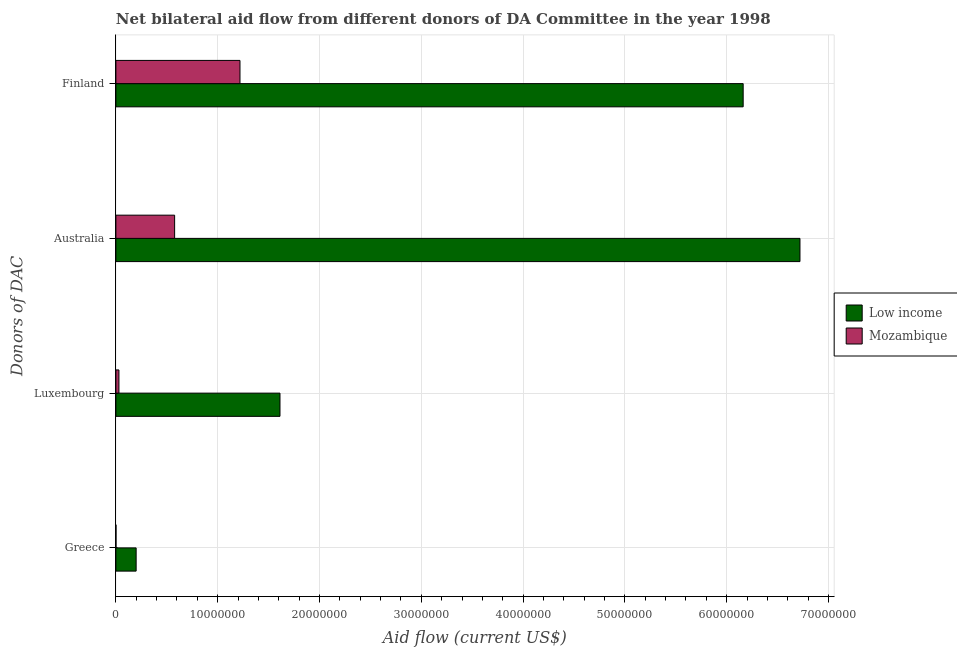How many groups of bars are there?
Provide a succinct answer. 4. What is the amount of aid given by greece in Mozambique?
Keep it short and to the point. 10000. Across all countries, what is the maximum amount of aid given by greece?
Your answer should be very brief. 1.99e+06. Across all countries, what is the minimum amount of aid given by greece?
Make the answer very short. 10000. In which country was the amount of aid given by greece minimum?
Offer a terse response. Mozambique. What is the total amount of aid given by greece in the graph?
Offer a terse response. 2.00e+06. What is the difference between the amount of aid given by luxembourg in Mozambique and that in Low income?
Keep it short and to the point. -1.58e+07. What is the difference between the amount of aid given by australia in Low income and the amount of aid given by finland in Mozambique?
Offer a very short reply. 5.50e+07. What is the average amount of aid given by finland per country?
Offer a very short reply. 3.69e+07. What is the difference between the amount of aid given by finland and amount of aid given by luxembourg in Low income?
Keep it short and to the point. 4.55e+07. What is the ratio of the amount of aid given by greece in Mozambique to that in Low income?
Offer a very short reply. 0.01. Is the amount of aid given by luxembourg in Mozambique less than that in Low income?
Give a very brief answer. Yes. Is the difference between the amount of aid given by luxembourg in Mozambique and Low income greater than the difference between the amount of aid given by finland in Mozambique and Low income?
Your answer should be very brief. Yes. What is the difference between the highest and the second highest amount of aid given by greece?
Offer a very short reply. 1.98e+06. What is the difference between the highest and the lowest amount of aid given by finland?
Ensure brevity in your answer.  4.94e+07. In how many countries, is the amount of aid given by luxembourg greater than the average amount of aid given by luxembourg taken over all countries?
Offer a terse response. 1. Is the sum of the amount of aid given by greece in Low income and Mozambique greater than the maximum amount of aid given by australia across all countries?
Keep it short and to the point. No. What does the 2nd bar from the top in Australia represents?
Make the answer very short. Low income. What does the 2nd bar from the bottom in Greece represents?
Offer a terse response. Mozambique. What is the difference between two consecutive major ticks on the X-axis?
Provide a short and direct response. 1.00e+07. Does the graph contain grids?
Provide a succinct answer. Yes. How many legend labels are there?
Offer a very short reply. 2. What is the title of the graph?
Offer a terse response. Net bilateral aid flow from different donors of DA Committee in the year 1998. Does "Tonga" appear as one of the legend labels in the graph?
Give a very brief answer. No. What is the label or title of the X-axis?
Your answer should be compact. Aid flow (current US$). What is the label or title of the Y-axis?
Your answer should be very brief. Donors of DAC. What is the Aid flow (current US$) of Low income in Greece?
Provide a succinct answer. 1.99e+06. What is the Aid flow (current US$) of Low income in Luxembourg?
Ensure brevity in your answer.  1.61e+07. What is the Aid flow (current US$) of Low income in Australia?
Provide a short and direct response. 6.72e+07. What is the Aid flow (current US$) of Mozambique in Australia?
Keep it short and to the point. 5.77e+06. What is the Aid flow (current US$) in Low income in Finland?
Offer a very short reply. 6.16e+07. What is the Aid flow (current US$) of Mozambique in Finland?
Your answer should be very brief. 1.22e+07. Across all Donors of DAC, what is the maximum Aid flow (current US$) of Low income?
Your answer should be very brief. 6.72e+07. Across all Donors of DAC, what is the maximum Aid flow (current US$) in Mozambique?
Offer a very short reply. 1.22e+07. Across all Donors of DAC, what is the minimum Aid flow (current US$) in Low income?
Give a very brief answer. 1.99e+06. What is the total Aid flow (current US$) in Low income in the graph?
Ensure brevity in your answer.  1.47e+08. What is the total Aid flow (current US$) in Mozambique in the graph?
Give a very brief answer. 1.83e+07. What is the difference between the Aid flow (current US$) of Low income in Greece and that in Luxembourg?
Your response must be concise. -1.41e+07. What is the difference between the Aid flow (current US$) in Low income in Greece and that in Australia?
Your response must be concise. -6.52e+07. What is the difference between the Aid flow (current US$) of Mozambique in Greece and that in Australia?
Keep it short and to the point. -5.76e+06. What is the difference between the Aid flow (current US$) in Low income in Greece and that in Finland?
Ensure brevity in your answer.  -5.96e+07. What is the difference between the Aid flow (current US$) of Mozambique in Greece and that in Finland?
Keep it short and to the point. -1.22e+07. What is the difference between the Aid flow (current US$) of Low income in Luxembourg and that in Australia?
Provide a short and direct response. -5.11e+07. What is the difference between the Aid flow (current US$) in Mozambique in Luxembourg and that in Australia?
Your answer should be compact. -5.47e+06. What is the difference between the Aid flow (current US$) of Low income in Luxembourg and that in Finland?
Make the answer very short. -4.55e+07. What is the difference between the Aid flow (current US$) in Mozambique in Luxembourg and that in Finland?
Keep it short and to the point. -1.19e+07. What is the difference between the Aid flow (current US$) in Low income in Australia and that in Finland?
Keep it short and to the point. 5.58e+06. What is the difference between the Aid flow (current US$) of Mozambique in Australia and that in Finland?
Your answer should be very brief. -6.42e+06. What is the difference between the Aid flow (current US$) of Low income in Greece and the Aid flow (current US$) of Mozambique in Luxembourg?
Your response must be concise. 1.69e+06. What is the difference between the Aid flow (current US$) of Low income in Greece and the Aid flow (current US$) of Mozambique in Australia?
Offer a very short reply. -3.78e+06. What is the difference between the Aid flow (current US$) in Low income in Greece and the Aid flow (current US$) in Mozambique in Finland?
Give a very brief answer. -1.02e+07. What is the difference between the Aid flow (current US$) in Low income in Luxembourg and the Aid flow (current US$) in Mozambique in Australia?
Give a very brief answer. 1.04e+07. What is the difference between the Aid flow (current US$) of Low income in Luxembourg and the Aid flow (current US$) of Mozambique in Finland?
Keep it short and to the point. 3.93e+06. What is the difference between the Aid flow (current US$) in Low income in Australia and the Aid flow (current US$) in Mozambique in Finland?
Provide a succinct answer. 5.50e+07. What is the average Aid flow (current US$) of Low income per Donors of DAC?
Make the answer very short. 3.67e+07. What is the average Aid flow (current US$) in Mozambique per Donors of DAC?
Your answer should be compact. 4.57e+06. What is the difference between the Aid flow (current US$) of Low income and Aid flow (current US$) of Mozambique in Greece?
Offer a terse response. 1.98e+06. What is the difference between the Aid flow (current US$) in Low income and Aid flow (current US$) in Mozambique in Luxembourg?
Offer a terse response. 1.58e+07. What is the difference between the Aid flow (current US$) of Low income and Aid flow (current US$) of Mozambique in Australia?
Provide a short and direct response. 6.14e+07. What is the difference between the Aid flow (current US$) in Low income and Aid flow (current US$) in Mozambique in Finland?
Offer a very short reply. 4.94e+07. What is the ratio of the Aid flow (current US$) in Low income in Greece to that in Luxembourg?
Your answer should be very brief. 0.12. What is the ratio of the Aid flow (current US$) of Low income in Greece to that in Australia?
Your answer should be compact. 0.03. What is the ratio of the Aid flow (current US$) in Mozambique in Greece to that in Australia?
Offer a very short reply. 0. What is the ratio of the Aid flow (current US$) of Low income in Greece to that in Finland?
Make the answer very short. 0.03. What is the ratio of the Aid flow (current US$) in Mozambique in Greece to that in Finland?
Provide a succinct answer. 0. What is the ratio of the Aid flow (current US$) of Low income in Luxembourg to that in Australia?
Offer a very short reply. 0.24. What is the ratio of the Aid flow (current US$) of Mozambique in Luxembourg to that in Australia?
Provide a succinct answer. 0.05. What is the ratio of the Aid flow (current US$) of Low income in Luxembourg to that in Finland?
Make the answer very short. 0.26. What is the ratio of the Aid flow (current US$) in Mozambique in Luxembourg to that in Finland?
Provide a succinct answer. 0.02. What is the ratio of the Aid flow (current US$) of Low income in Australia to that in Finland?
Give a very brief answer. 1.09. What is the ratio of the Aid flow (current US$) of Mozambique in Australia to that in Finland?
Offer a terse response. 0.47. What is the difference between the highest and the second highest Aid flow (current US$) in Low income?
Give a very brief answer. 5.58e+06. What is the difference between the highest and the second highest Aid flow (current US$) in Mozambique?
Offer a very short reply. 6.42e+06. What is the difference between the highest and the lowest Aid flow (current US$) of Low income?
Provide a succinct answer. 6.52e+07. What is the difference between the highest and the lowest Aid flow (current US$) in Mozambique?
Ensure brevity in your answer.  1.22e+07. 